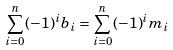<formula> <loc_0><loc_0><loc_500><loc_500>\sum _ { i = 0 } ^ { n } ( - 1 ) ^ { i } b _ { i } = \sum _ { i = 0 } ^ { n } ( - 1 ) ^ { i } m _ { i }</formula> 